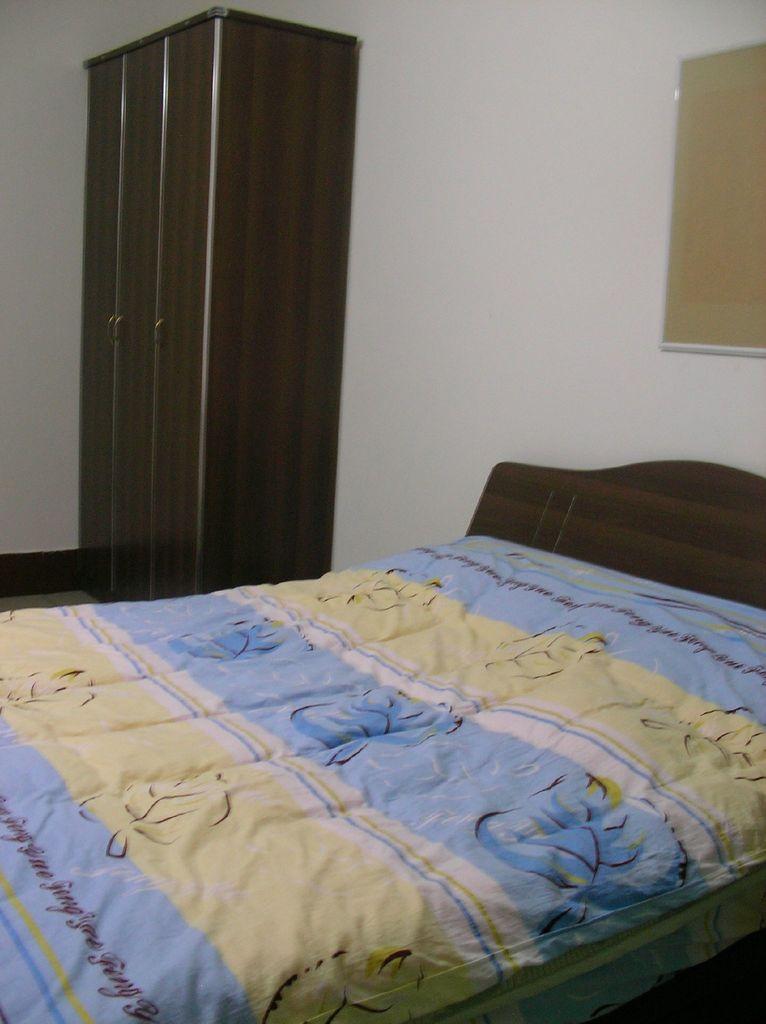How would you summarize this image in a sentence or two? In this image there is a bed with a blanket, wardrobe, frame attached to the wall. 